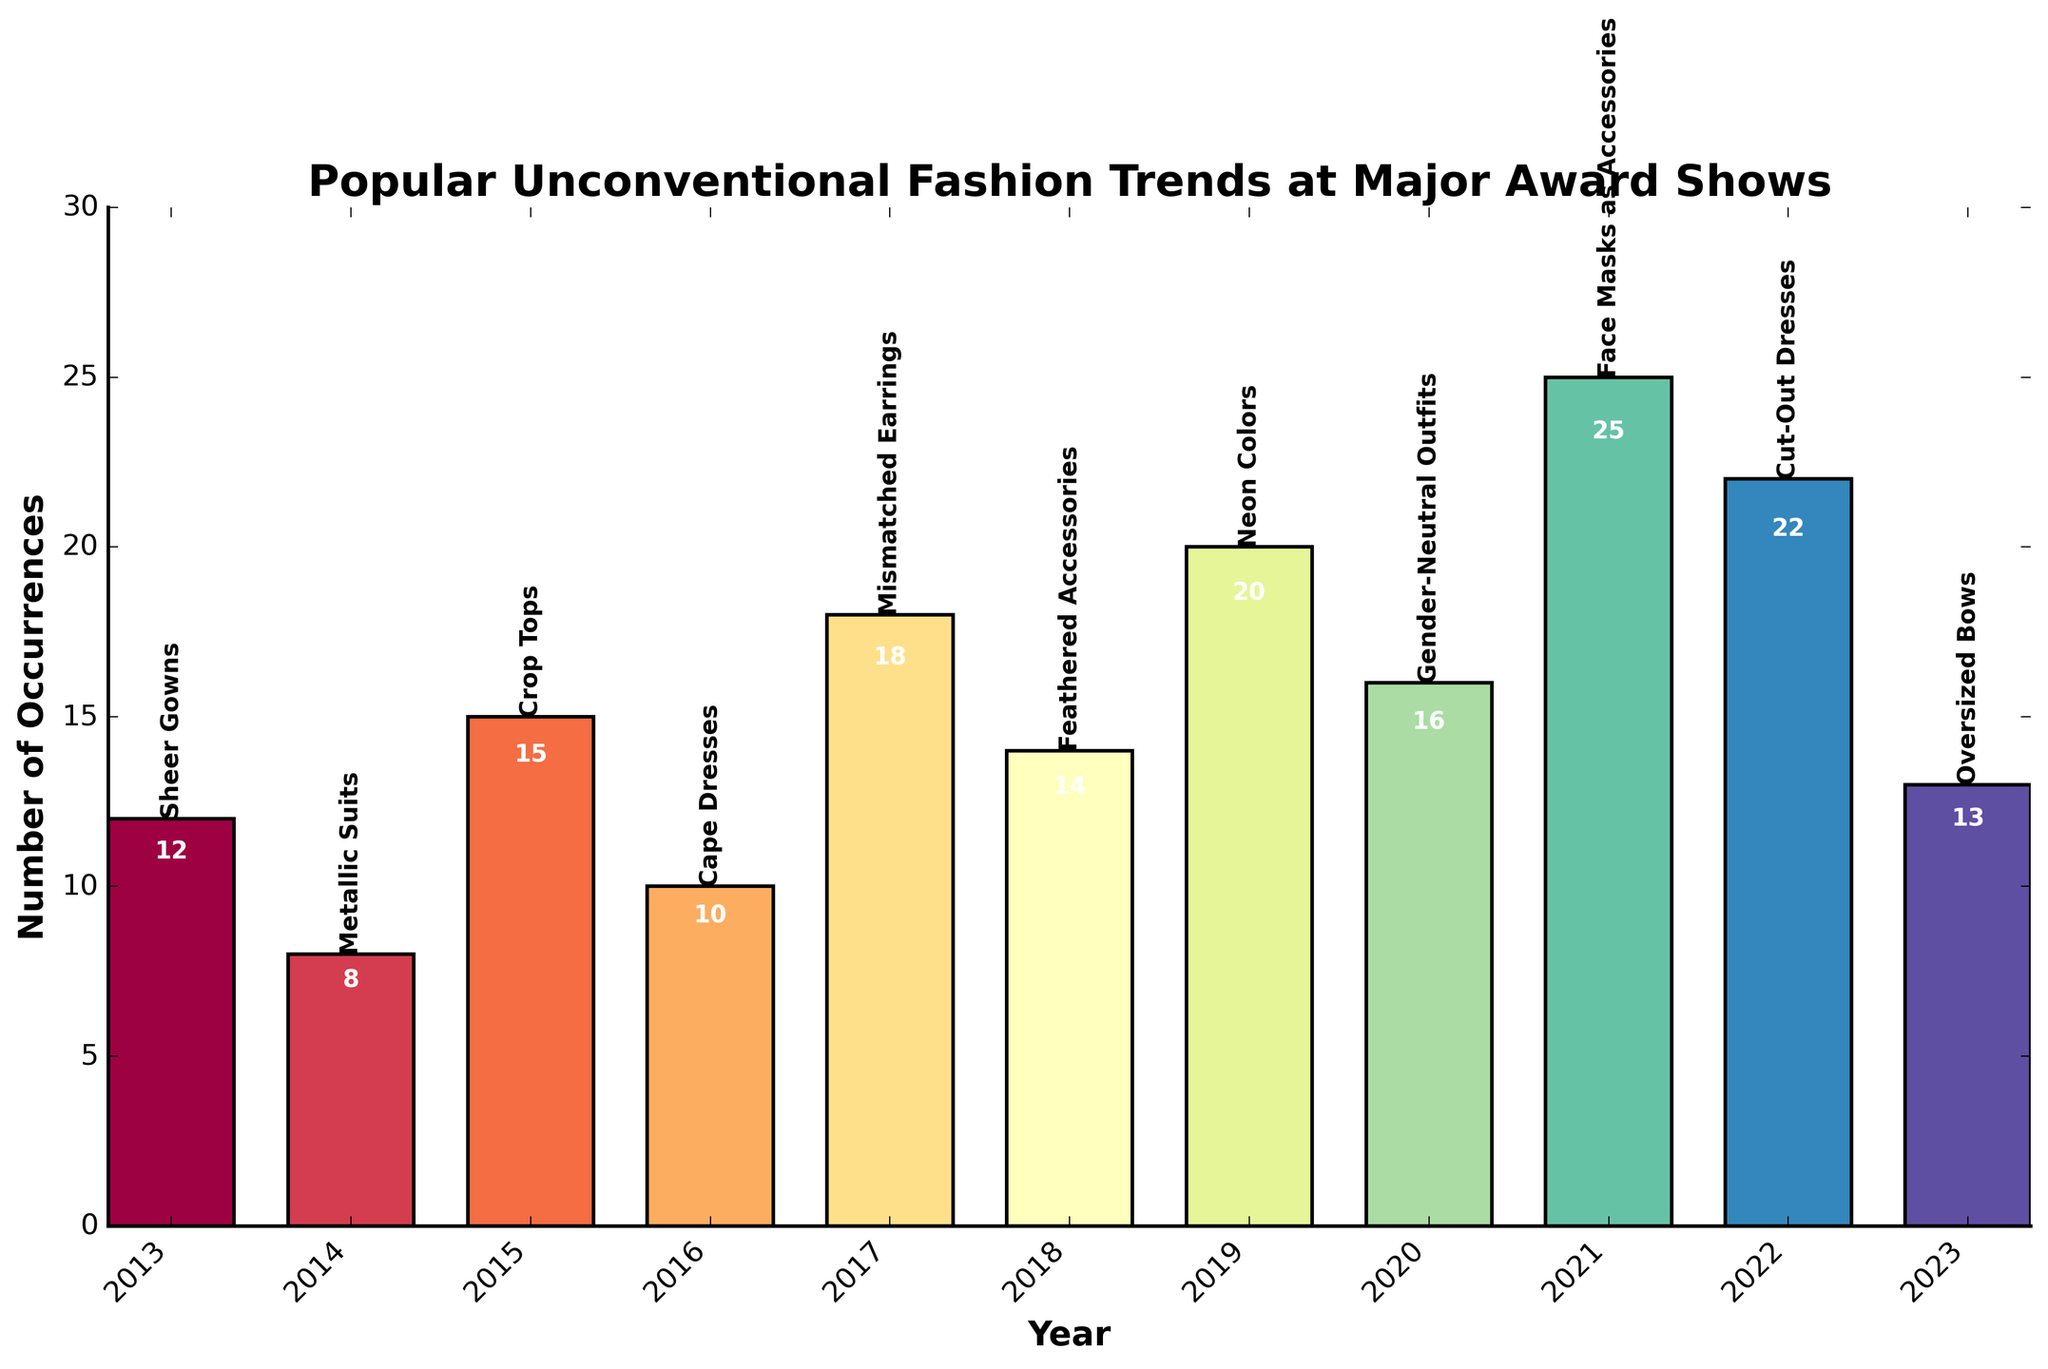What year had the most popular unconventional fashion trend? The year with the most occurrences of a single trend can be determined by looking for the highest bar on the chart. In 2021, "Face Masks as Accessories" had the highest occurrence with 25.
Answer: 2021 Which trend had more occurrences: Feathered Accessories or Gender-Neutral Outfits? Comparing the bars for Feathered Accessories in 2018 and Gender-Neutral Outfits in 2020, we see that Gender-Neutral Outfits has 16 while Feathered Accessories has 14.
Answer: Gender-Neutral Outfits What's the difference in occurrences between Crop Tops in 2015 and Oversized Bows in 2023? To solve this, subtract the occurrences of Oversized Bows (13) from Crop Tops (15): 15 - 13 = 2.
Answer: 2 Which trend had the lowest occurrences? The lowest bar on the chart corresponds to Metallic Suits in 2014 with 8 occurrences.
Answer: Metallic Suits How many trends had more than 15 occurrences? By counting the bars with heights greater than 15, we find that there are five trends: Mismatched Earrings (18), Neon Colors (20), Gender-Neutral Outfits (16), Face Masks as Accessories (25), and Cut-Out Dresses (22).
Answer: 5 Compare the occurrences of Sheer Gowns in 2013 and Cape Dresses in 2016. Which one is higher and by how much? Sheer Gowns in 2013 had 12 occurrences, while Cape Dresses in 2016 had 10. The difference is 12 - 10 = 2, so Sheer Gowns had 2 more occurrences.
Answer: Sheer Gowns, 2 What is the total number of occurrences for trends from the years 2019, 2020, and 2021 combined? Adding the occurrences: 2019 (Neon Colors, 20), 2020 (Gender-Neutral Outfits, 16), and 2021 (Face Masks as Accessories, 25): 20 + 16 + 25 = 61.
Answer: 61 Between the trends "Cut-Out Dresses" and "Oversized Bows," which year had a more visually prominent bar in terms of height? Cut-Out Dresses in 2022 had more occurrences (22) compared to Oversized Bows in 2023 (13), so the bar for Cut-Out Dresses is taller and more visually prominent.
Answer: Cut-Out Dresses What is the trend for 2017 and how many occurrences did it have? Looking at the bar labeled "2017," the trend is "Mismatched Earrings" with 18 occurrences.
Answer: Mismatched Earrings, 18 